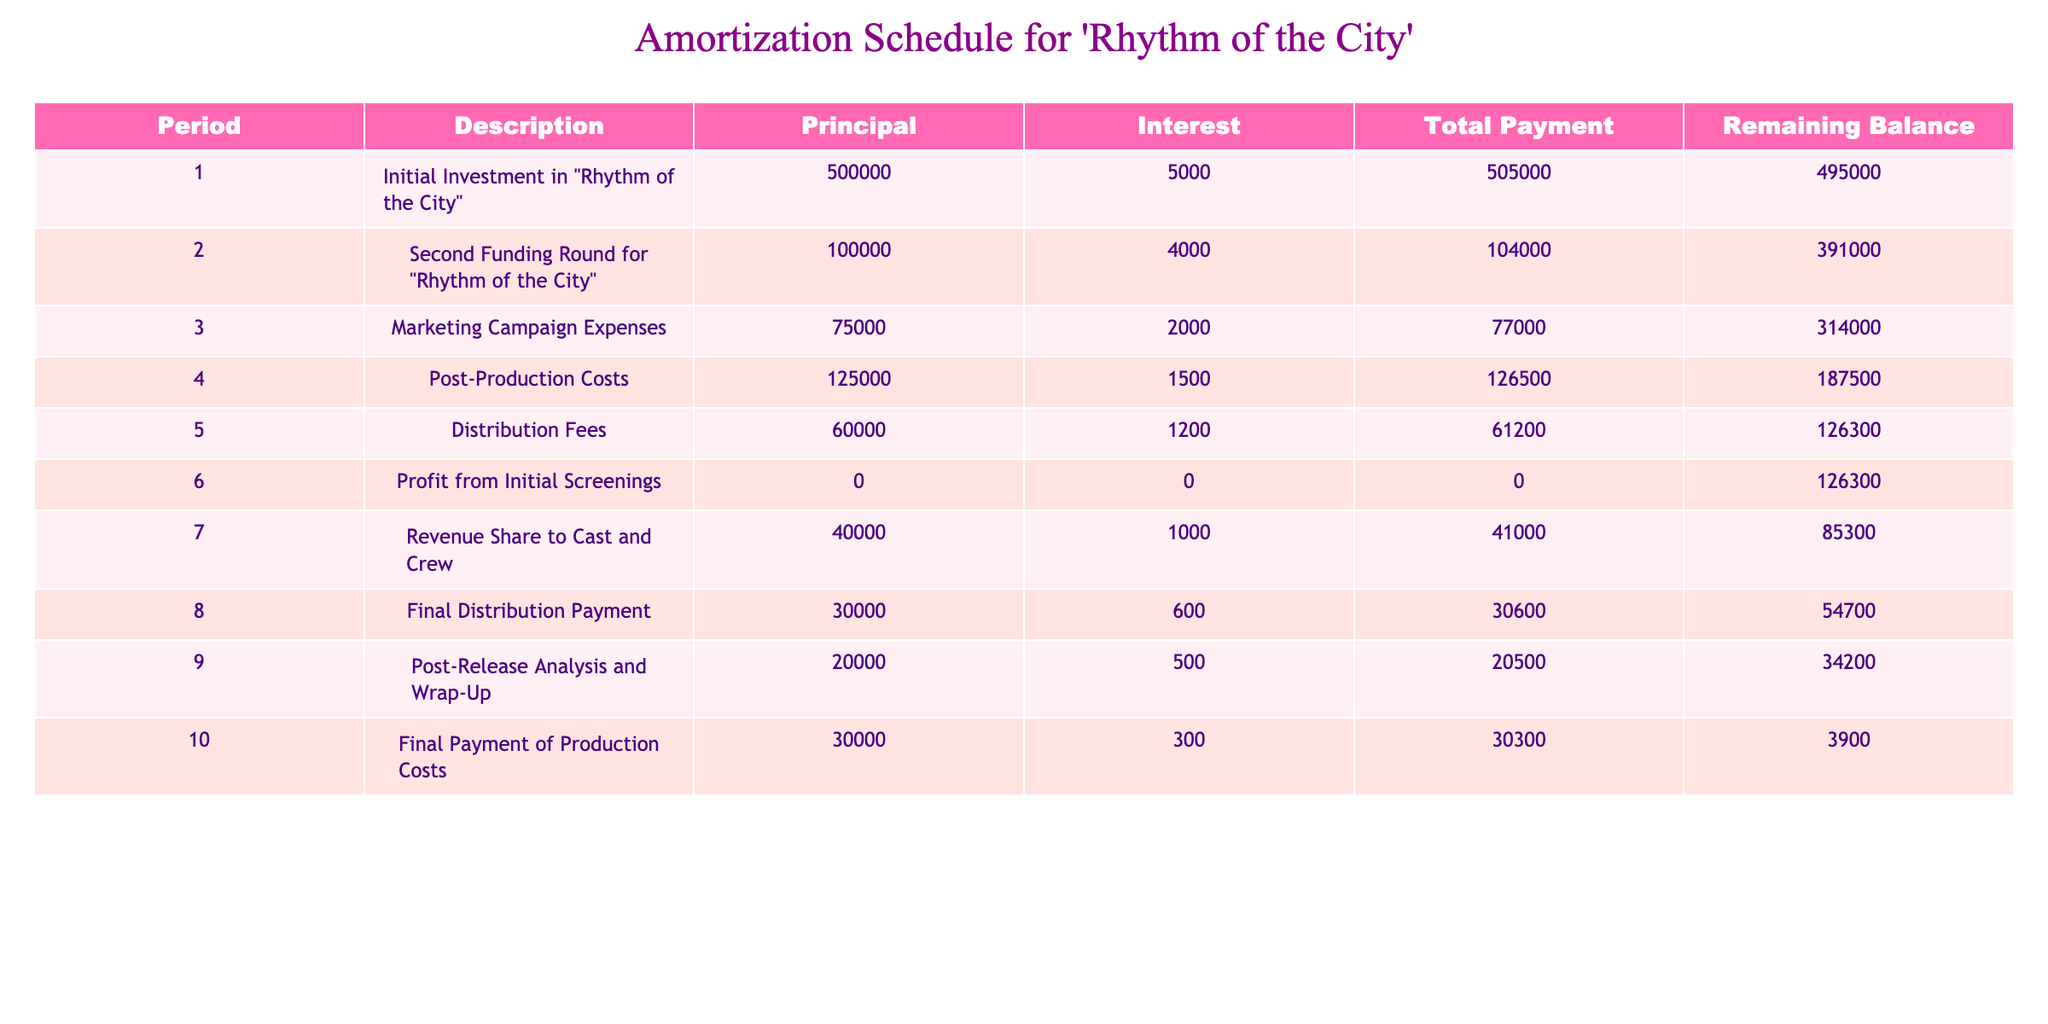What was the total principal paid during the marketing campaign expenses? According to the table, the marketing campaign expenses had a principal of 75000.
Answer: 75000 What is the remaining balance after the second funding round? After the second funding round, the initial principal of 500000 was reduced by the second funding amount of 100000. Thus, the remaining balance was 500000 - 100000 = 391000.
Answer: 391000 What is the total interest paid throughout all periods? By adding the interest from each period: 5000 + 4000 + 2000 + 1500 + 1200 + 0 + 1000 + 600 + 500 + 300 = 15200.
Answer: 15200 Were there any periods with zero payments? Yes, period 6 mentions "Profit from Initial Screenings" with a total payment of 0.
Answer: Yes What is the average total payment made over the entire schedule? The total payments are: 505000 + 104000 + 77000 + 126500 + 61200 + 0 + 41000 + 30600 + 20500 + 30300 = 813100. With 10 periods, the average total payment is 813100 / 10 = 81310.
Answer: 81310 What is the difference in remaining balance between the final payment of production costs and the initial investment? The final remaining balance is 3900, and the initial investment was 500000. Thus, the difference is 500000 - 3900 = 496100.
Answer: 496100 Did the revenue share to cast and crew decrease the remaining balance? Yes, the remaining balance decreased from 126300 to 85300 after the revenue share payment.
Answer: Yes What was the highest total payment recorded in a single period? The highest total payment listed is 505000 during the initial investment stage.
Answer: 505000 How much principal was paid in the period with marketing campaign expenses compared to post-production costs? The principal paid during the marketing campaign was 75000, and for post-production costs, it was 125000. Comparing these two values shows that 125000 is higher than 75000.
Answer: 125000 (greater than 75000) 